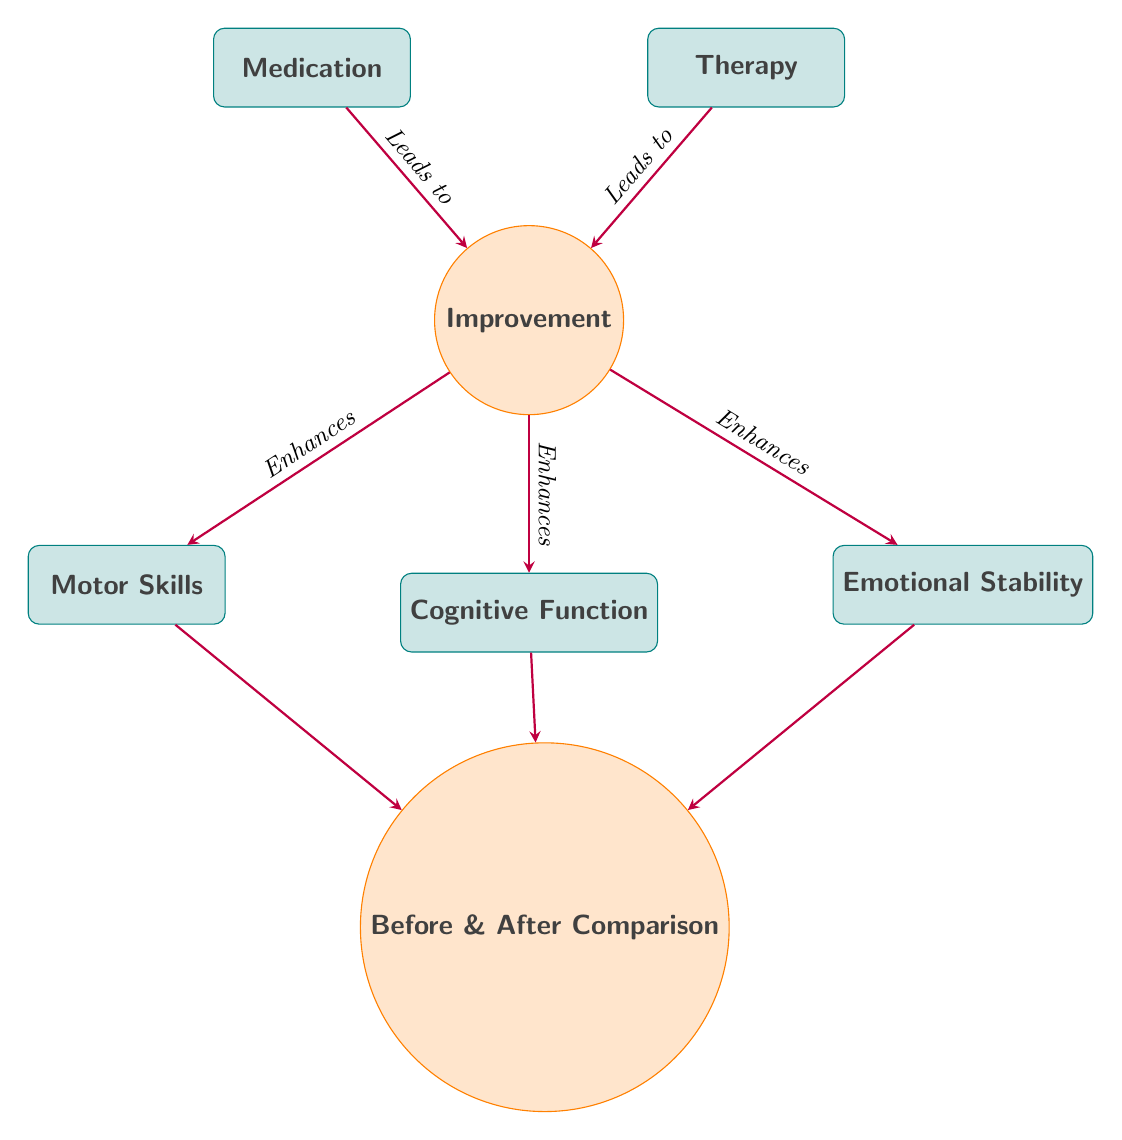What is the central node in the diagram? The central node in the diagram represents "Improvement" and is situated below the medication and therapy nodes, signifying the overall effect of both on brain function.
Answer: Improvement How many outcomes are identified in the diagram? There are three outcomes identified in the diagram, which are "Motor Skills," "Cognitive Function," and "Emotional Stability." These are shown as nodes branching off from the "Improvement" node.
Answer: 3 What does medication lead to? Medication leads to "Improvement" as indicated by the arrow pointing from the "Medication" node to the "Improvement" node, showing that medication has a direct positive effect.
Answer: Improvement What is the relationship between "Therapy" and "Improvement"? The relationship is that "Therapy" leads to "Improvement," as shown by the arrow connecting the "Therapy" node to the "Improvement" node, indicating therapy also contributes positively.
Answer: Leads to Improvement Which aspect is directly enhanced according to the diagram? The aspects directly enhanced according to the diagram are "Motor Skills," "Cognitive Function," and "Emotional Stability," all connected to the "Improvement" node with arrows showing their positive influence.
Answer: Motor Skills, Cognitive Function, Emotional Stability What is the comparison showing in relation to the other nodes? The comparison node shows the "Before & After Comparison," illustrating the change in brain function resulting from both medication and therapy interventions, placed below the other outcome nodes.
Answer: Before & After Comparison How does "Motor Skills" relate to the "Improvement" node? "Motor Skills" is enhanced by the "Improvement" node, indicating that improvements in overall function positively impact motor skills, depicted by the arrow from "Improvement" to "Motor Skills."
Answer: Enhances What color represents the therapy and medication boxes? The therapy and medication boxes are represented in teal color, as specified in the diagram styling, highlighting their significance in the treatment process.
Answer: Teal What node is situated below the improvement node? The node situated below the "Improvement" node is the "Before & After Comparison," which captures the overall effects of the treatments over time, shown at a lower level in the diagram.
Answer: Before & After Comparison 